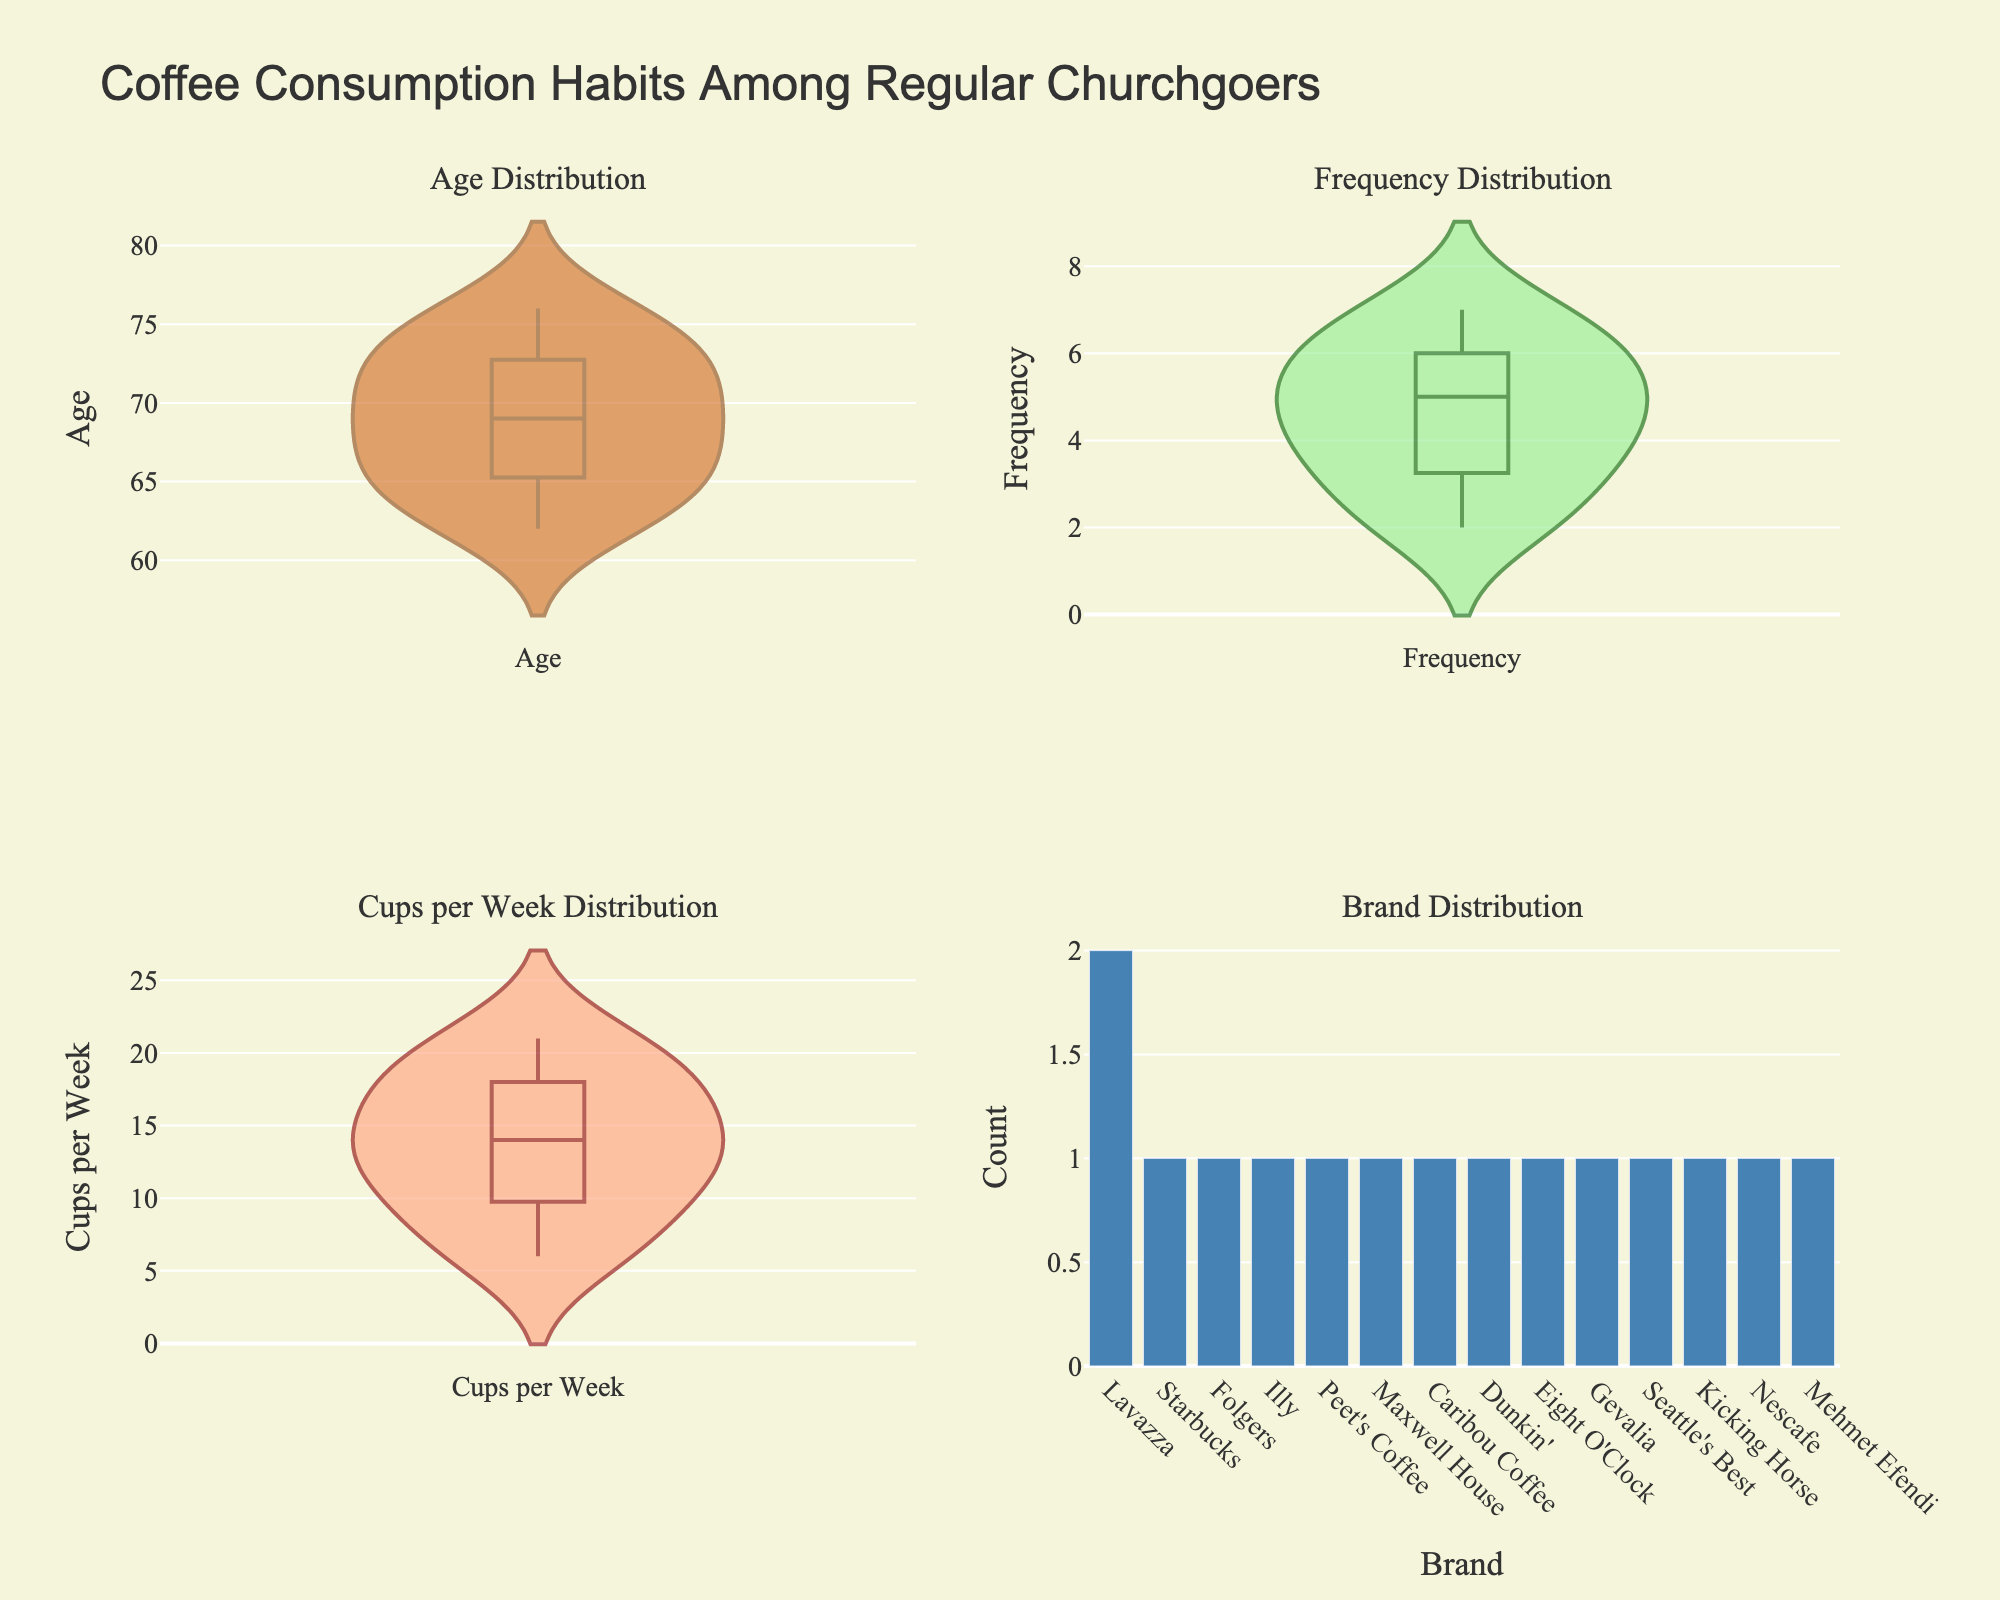What is the title of the figure? The title is displayed at the top of the figure, in larger, bold text. It provides an overall description of what the figure represents.
Answer: Coffee Consumption Habits Among Regular Churchgoers Which variable has the widest spread in the violin plots? By comparing the width of the violin plots, we see the spread indicates the variability of the data. The violin plot with the widest distribution has the most variability in the values.
Answer: Age Which coffee brand is the most common among the churchgoers? Look at the bar chart in the bottom-right subplot. The height of the bars represents the count of churchgoers preferring each coffee brand. The tallest bar indicates the most common brand.
Answer: Lavazza What is the median frequency of coffee consumption per week? The violin plot for Frequency Distribution shows the median value with a boxed line inside the violin.
Answer: 5 Which subplot shows a coffee consumption habit that varies the least? By comparing the violin plots and the bar chart, we notice the least variation in the data's spread. The tighter the distribution or fewer unique counts, the less variation.
Answer: Brand Distribution How many cups of coffee per week do most churchgoers drink? Check the Cups per Week Distribution violin plot. The bulk of the data points clump around the most frequent value.
Answer: 18 How does the median age compare to the median number of cups of coffee consumed per week? Observe the medians in the respective violin plots. They are visually marked with a horizontal line within the plot. Compare the median line positions.
Answer: Median age is higher Which age group consumes the most coffee on average? Compare the 'Age' violin plot with the 'Cups per Week' violin plot. Focus on the central tendency (median) to observe which age group aligns with higher coffee consumption per week.
Answer: Age group around 62-68 What's the relationship between coffee frequency and age? Analyze the 'Frequency' and 'Age' violin plots. Look for patterns indicating whether higher frequencies of consumption correspond to a particular age range.
Answer: Higher frequency around ages 66-68 What is the most common frequency of coffee consumption among the participants? The highest density or the thickest part of the violin plot for Frequency Distribution represents the most common frequency value.
Answer: 5 